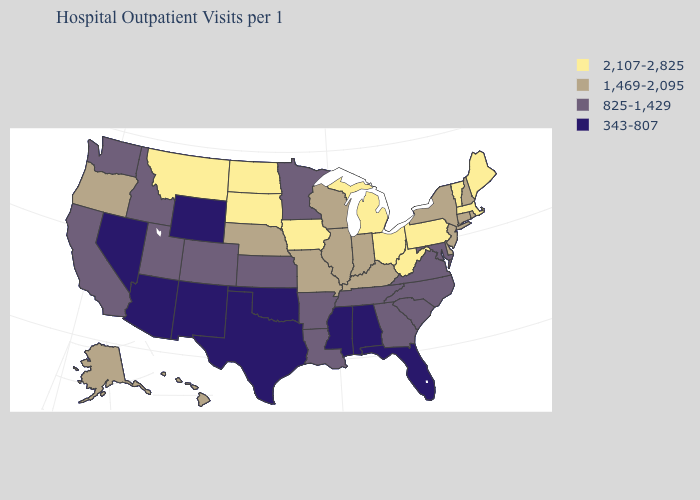What is the highest value in the West ?
Give a very brief answer. 2,107-2,825. Name the states that have a value in the range 825-1,429?
Answer briefly. Arkansas, California, Colorado, Georgia, Idaho, Kansas, Louisiana, Maryland, Minnesota, North Carolina, South Carolina, Tennessee, Utah, Virginia, Washington. Which states have the highest value in the USA?
Quick response, please. Iowa, Maine, Massachusetts, Michigan, Montana, North Dakota, Ohio, Pennsylvania, South Dakota, Vermont, West Virginia. Name the states that have a value in the range 825-1,429?
Give a very brief answer. Arkansas, California, Colorado, Georgia, Idaho, Kansas, Louisiana, Maryland, Minnesota, North Carolina, South Carolina, Tennessee, Utah, Virginia, Washington. What is the highest value in the USA?
Give a very brief answer. 2,107-2,825. What is the value of Idaho?
Write a very short answer. 825-1,429. Which states hav the highest value in the South?
Short answer required. West Virginia. Does the map have missing data?
Be succinct. No. What is the value of Wisconsin?
Keep it brief. 1,469-2,095. What is the value of Hawaii?
Write a very short answer. 1,469-2,095. Name the states that have a value in the range 1,469-2,095?
Be succinct. Alaska, Connecticut, Delaware, Hawaii, Illinois, Indiana, Kentucky, Missouri, Nebraska, New Hampshire, New Jersey, New York, Oregon, Rhode Island, Wisconsin. Is the legend a continuous bar?
Short answer required. No. Name the states that have a value in the range 343-807?
Answer briefly. Alabama, Arizona, Florida, Mississippi, Nevada, New Mexico, Oklahoma, Texas, Wyoming. What is the value of Tennessee?
Concise answer only. 825-1,429. Name the states that have a value in the range 825-1,429?
Concise answer only. Arkansas, California, Colorado, Georgia, Idaho, Kansas, Louisiana, Maryland, Minnesota, North Carolina, South Carolina, Tennessee, Utah, Virginia, Washington. 